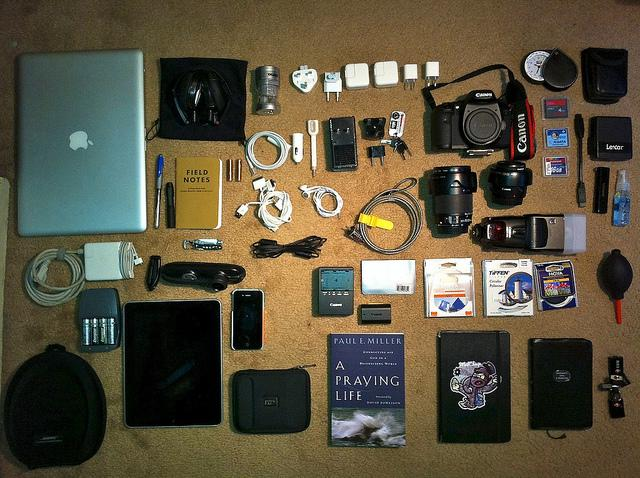The book was based on a series of what by the author? paul miller 